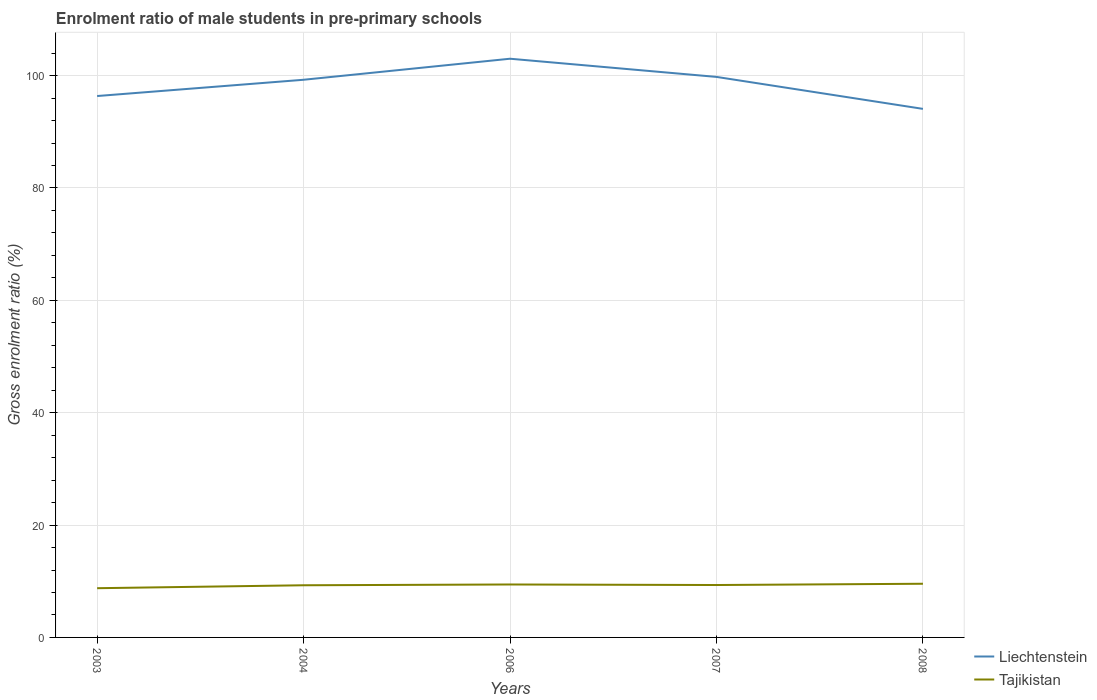How many different coloured lines are there?
Your response must be concise. 2. Across all years, what is the maximum enrolment ratio of male students in pre-primary schools in Liechtenstein?
Ensure brevity in your answer.  94.07. In which year was the enrolment ratio of male students in pre-primary schools in Liechtenstein maximum?
Provide a succinct answer. 2008. What is the total enrolment ratio of male students in pre-primary schools in Liechtenstein in the graph?
Your response must be concise. 3.24. What is the difference between the highest and the second highest enrolment ratio of male students in pre-primary schools in Tajikistan?
Give a very brief answer. 0.79. What is the difference between the highest and the lowest enrolment ratio of male students in pre-primary schools in Liechtenstein?
Your answer should be very brief. 3. Is the enrolment ratio of male students in pre-primary schools in Liechtenstein strictly greater than the enrolment ratio of male students in pre-primary schools in Tajikistan over the years?
Your answer should be very brief. No. Are the values on the major ticks of Y-axis written in scientific E-notation?
Your answer should be very brief. No. Does the graph contain any zero values?
Your response must be concise. No. Where does the legend appear in the graph?
Make the answer very short. Bottom right. How many legend labels are there?
Provide a succinct answer. 2. How are the legend labels stacked?
Your response must be concise. Vertical. What is the title of the graph?
Keep it short and to the point. Enrolment ratio of male students in pre-primary schools. What is the label or title of the X-axis?
Provide a succinct answer. Years. What is the Gross enrolment ratio (%) of Liechtenstein in 2003?
Provide a short and direct response. 96.36. What is the Gross enrolment ratio (%) in Tajikistan in 2003?
Make the answer very short. 8.76. What is the Gross enrolment ratio (%) in Liechtenstein in 2004?
Your answer should be very brief. 99.26. What is the Gross enrolment ratio (%) in Tajikistan in 2004?
Your answer should be compact. 9.28. What is the Gross enrolment ratio (%) of Liechtenstein in 2006?
Provide a succinct answer. 103. What is the Gross enrolment ratio (%) in Tajikistan in 2006?
Your answer should be compact. 9.42. What is the Gross enrolment ratio (%) of Liechtenstein in 2007?
Your response must be concise. 99.76. What is the Gross enrolment ratio (%) in Tajikistan in 2007?
Ensure brevity in your answer.  9.33. What is the Gross enrolment ratio (%) in Liechtenstein in 2008?
Keep it short and to the point. 94.07. What is the Gross enrolment ratio (%) of Tajikistan in 2008?
Keep it short and to the point. 9.55. Across all years, what is the maximum Gross enrolment ratio (%) of Liechtenstein?
Offer a terse response. 103. Across all years, what is the maximum Gross enrolment ratio (%) in Tajikistan?
Make the answer very short. 9.55. Across all years, what is the minimum Gross enrolment ratio (%) of Liechtenstein?
Offer a very short reply. 94.07. Across all years, what is the minimum Gross enrolment ratio (%) of Tajikistan?
Ensure brevity in your answer.  8.76. What is the total Gross enrolment ratio (%) in Liechtenstein in the graph?
Make the answer very short. 492.45. What is the total Gross enrolment ratio (%) of Tajikistan in the graph?
Keep it short and to the point. 46.35. What is the difference between the Gross enrolment ratio (%) of Liechtenstein in 2003 and that in 2004?
Your answer should be compact. -2.9. What is the difference between the Gross enrolment ratio (%) in Tajikistan in 2003 and that in 2004?
Keep it short and to the point. -0.52. What is the difference between the Gross enrolment ratio (%) in Liechtenstein in 2003 and that in 2006?
Provide a succinct answer. -6.64. What is the difference between the Gross enrolment ratio (%) in Tajikistan in 2003 and that in 2006?
Offer a terse response. -0.66. What is the difference between the Gross enrolment ratio (%) in Liechtenstein in 2003 and that in 2007?
Keep it short and to the point. -3.4. What is the difference between the Gross enrolment ratio (%) of Tajikistan in 2003 and that in 2007?
Provide a succinct answer. -0.57. What is the difference between the Gross enrolment ratio (%) in Liechtenstein in 2003 and that in 2008?
Provide a succinct answer. 2.29. What is the difference between the Gross enrolment ratio (%) in Tajikistan in 2003 and that in 2008?
Your answer should be compact. -0.79. What is the difference between the Gross enrolment ratio (%) in Liechtenstein in 2004 and that in 2006?
Provide a succinct answer. -3.74. What is the difference between the Gross enrolment ratio (%) of Tajikistan in 2004 and that in 2006?
Keep it short and to the point. -0.14. What is the difference between the Gross enrolment ratio (%) in Liechtenstein in 2004 and that in 2007?
Give a very brief answer. -0.51. What is the difference between the Gross enrolment ratio (%) in Tajikistan in 2004 and that in 2007?
Keep it short and to the point. -0.05. What is the difference between the Gross enrolment ratio (%) of Liechtenstein in 2004 and that in 2008?
Your answer should be compact. 5.18. What is the difference between the Gross enrolment ratio (%) in Tajikistan in 2004 and that in 2008?
Ensure brevity in your answer.  -0.27. What is the difference between the Gross enrolment ratio (%) of Liechtenstein in 2006 and that in 2007?
Provide a succinct answer. 3.24. What is the difference between the Gross enrolment ratio (%) of Tajikistan in 2006 and that in 2007?
Give a very brief answer. 0.09. What is the difference between the Gross enrolment ratio (%) in Liechtenstein in 2006 and that in 2008?
Provide a succinct answer. 8.93. What is the difference between the Gross enrolment ratio (%) of Tajikistan in 2006 and that in 2008?
Your response must be concise. -0.13. What is the difference between the Gross enrolment ratio (%) of Liechtenstein in 2007 and that in 2008?
Your answer should be compact. 5.69. What is the difference between the Gross enrolment ratio (%) in Tajikistan in 2007 and that in 2008?
Your answer should be compact. -0.22. What is the difference between the Gross enrolment ratio (%) of Liechtenstein in 2003 and the Gross enrolment ratio (%) of Tajikistan in 2004?
Offer a very short reply. 87.08. What is the difference between the Gross enrolment ratio (%) of Liechtenstein in 2003 and the Gross enrolment ratio (%) of Tajikistan in 2006?
Offer a terse response. 86.94. What is the difference between the Gross enrolment ratio (%) of Liechtenstein in 2003 and the Gross enrolment ratio (%) of Tajikistan in 2007?
Your answer should be very brief. 87.03. What is the difference between the Gross enrolment ratio (%) of Liechtenstein in 2003 and the Gross enrolment ratio (%) of Tajikistan in 2008?
Keep it short and to the point. 86.8. What is the difference between the Gross enrolment ratio (%) of Liechtenstein in 2004 and the Gross enrolment ratio (%) of Tajikistan in 2006?
Offer a very short reply. 89.83. What is the difference between the Gross enrolment ratio (%) in Liechtenstein in 2004 and the Gross enrolment ratio (%) in Tajikistan in 2007?
Offer a very short reply. 89.93. What is the difference between the Gross enrolment ratio (%) in Liechtenstein in 2004 and the Gross enrolment ratio (%) in Tajikistan in 2008?
Your answer should be very brief. 89.7. What is the difference between the Gross enrolment ratio (%) of Liechtenstein in 2006 and the Gross enrolment ratio (%) of Tajikistan in 2007?
Your answer should be very brief. 93.67. What is the difference between the Gross enrolment ratio (%) of Liechtenstein in 2006 and the Gross enrolment ratio (%) of Tajikistan in 2008?
Keep it short and to the point. 93.45. What is the difference between the Gross enrolment ratio (%) in Liechtenstein in 2007 and the Gross enrolment ratio (%) in Tajikistan in 2008?
Your answer should be compact. 90.21. What is the average Gross enrolment ratio (%) in Liechtenstein per year?
Give a very brief answer. 98.49. What is the average Gross enrolment ratio (%) in Tajikistan per year?
Your answer should be compact. 9.27. In the year 2003, what is the difference between the Gross enrolment ratio (%) in Liechtenstein and Gross enrolment ratio (%) in Tajikistan?
Make the answer very short. 87.6. In the year 2004, what is the difference between the Gross enrolment ratio (%) of Liechtenstein and Gross enrolment ratio (%) of Tajikistan?
Provide a short and direct response. 89.97. In the year 2006, what is the difference between the Gross enrolment ratio (%) of Liechtenstein and Gross enrolment ratio (%) of Tajikistan?
Offer a terse response. 93.58. In the year 2007, what is the difference between the Gross enrolment ratio (%) of Liechtenstein and Gross enrolment ratio (%) of Tajikistan?
Give a very brief answer. 90.43. In the year 2008, what is the difference between the Gross enrolment ratio (%) of Liechtenstein and Gross enrolment ratio (%) of Tajikistan?
Your answer should be very brief. 84.52. What is the ratio of the Gross enrolment ratio (%) of Liechtenstein in 2003 to that in 2004?
Give a very brief answer. 0.97. What is the ratio of the Gross enrolment ratio (%) in Tajikistan in 2003 to that in 2004?
Your response must be concise. 0.94. What is the ratio of the Gross enrolment ratio (%) in Liechtenstein in 2003 to that in 2006?
Your answer should be very brief. 0.94. What is the ratio of the Gross enrolment ratio (%) in Tajikistan in 2003 to that in 2006?
Offer a very short reply. 0.93. What is the ratio of the Gross enrolment ratio (%) in Liechtenstein in 2003 to that in 2007?
Offer a terse response. 0.97. What is the ratio of the Gross enrolment ratio (%) of Tajikistan in 2003 to that in 2007?
Keep it short and to the point. 0.94. What is the ratio of the Gross enrolment ratio (%) of Liechtenstein in 2003 to that in 2008?
Offer a very short reply. 1.02. What is the ratio of the Gross enrolment ratio (%) in Tajikistan in 2003 to that in 2008?
Your response must be concise. 0.92. What is the ratio of the Gross enrolment ratio (%) of Liechtenstein in 2004 to that in 2006?
Give a very brief answer. 0.96. What is the ratio of the Gross enrolment ratio (%) in Liechtenstein in 2004 to that in 2007?
Provide a succinct answer. 0.99. What is the ratio of the Gross enrolment ratio (%) of Liechtenstein in 2004 to that in 2008?
Provide a short and direct response. 1.06. What is the ratio of the Gross enrolment ratio (%) in Tajikistan in 2004 to that in 2008?
Provide a succinct answer. 0.97. What is the ratio of the Gross enrolment ratio (%) of Liechtenstein in 2006 to that in 2007?
Give a very brief answer. 1.03. What is the ratio of the Gross enrolment ratio (%) of Liechtenstein in 2006 to that in 2008?
Offer a very short reply. 1.09. What is the ratio of the Gross enrolment ratio (%) in Tajikistan in 2006 to that in 2008?
Provide a succinct answer. 0.99. What is the ratio of the Gross enrolment ratio (%) in Liechtenstein in 2007 to that in 2008?
Your answer should be compact. 1.06. What is the ratio of the Gross enrolment ratio (%) in Tajikistan in 2007 to that in 2008?
Provide a succinct answer. 0.98. What is the difference between the highest and the second highest Gross enrolment ratio (%) in Liechtenstein?
Make the answer very short. 3.24. What is the difference between the highest and the second highest Gross enrolment ratio (%) of Tajikistan?
Ensure brevity in your answer.  0.13. What is the difference between the highest and the lowest Gross enrolment ratio (%) in Liechtenstein?
Make the answer very short. 8.93. What is the difference between the highest and the lowest Gross enrolment ratio (%) of Tajikistan?
Your answer should be compact. 0.79. 